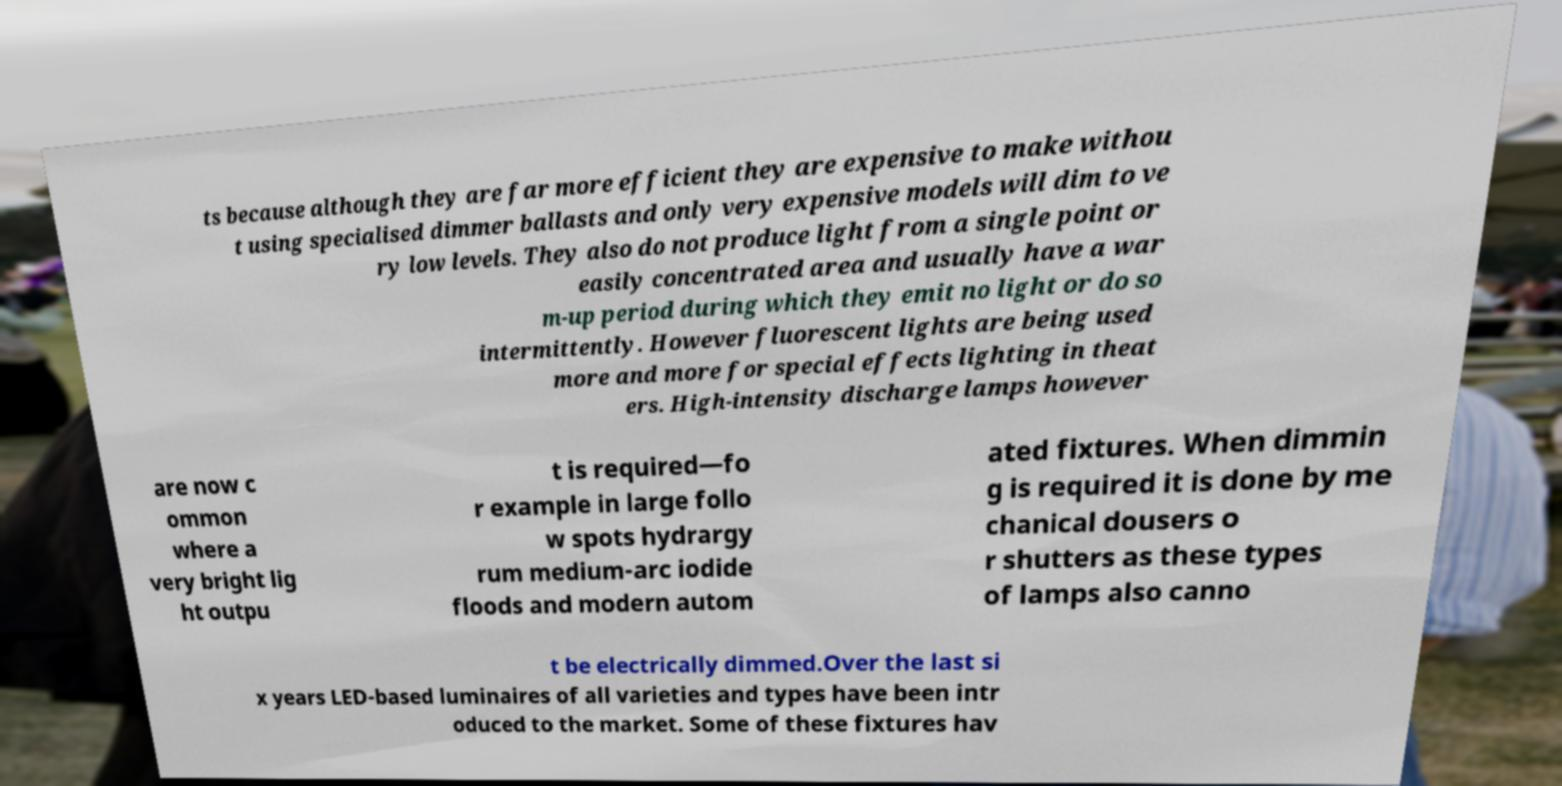I need the written content from this picture converted into text. Can you do that? ts because although they are far more efficient they are expensive to make withou t using specialised dimmer ballasts and only very expensive models will dim to ve ry low levels. They also do not produce light from a single point or easily concentrated area and usually have a war m-up period during which they emit no light or do so intermittently. However fluorescent lights are being used more and more for special effects lighting in theat ers. High-intensity discharge lamps however are now c ommon where a very bright lig ht outpu t is required—fo r example in large follo w spots hydrargy rum medium-arc iodide floods and modern autom ated fixtures. When dimmin g is required it is done by me chanical dousers o r shutters as these types of lamps also canno t be electrically dimmed.Over the last si x years LED-based luminaires of all varieties and types have been intr oduced to the market. Some of these fixtures hav 